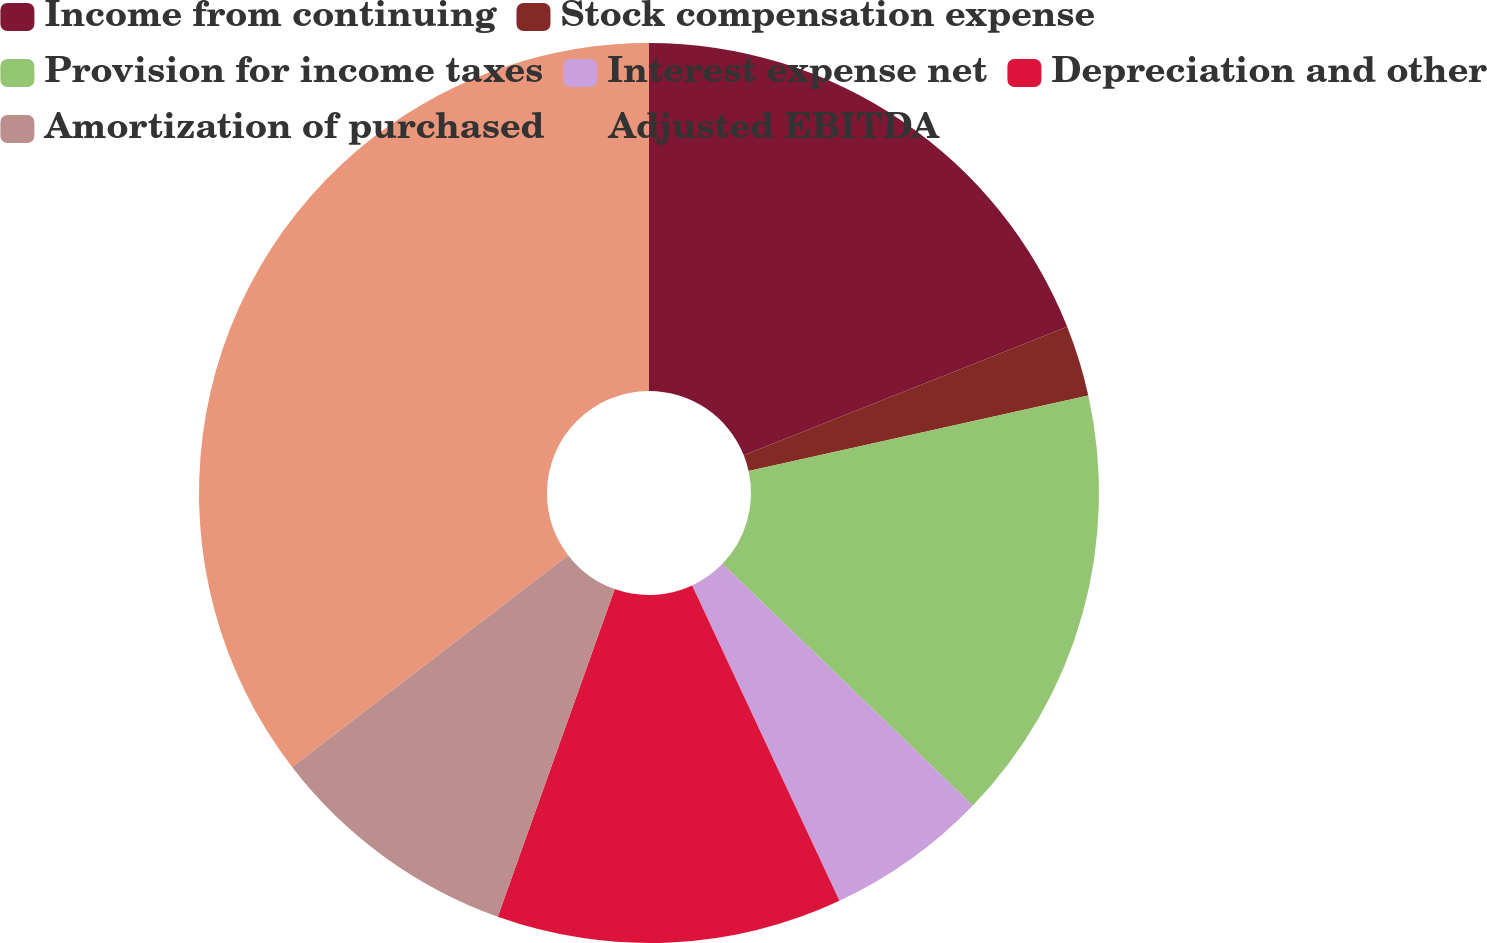<chart> <loc_0><loc_0><loc_500><loc_500><pie_chart><fcel>Income from continuing<fcel>Stock compensation expense<fcel>Provision for income taxes<fcel>Interest expense net<fcel>Depreciation and other<fcel>Amortization of purchased<fcel>Adjusted EBITDA<nl><fcel>18.98%<fcel>2.54%<fcel>15.69%<fcel>5.83%<fcel>12.41%<fcel>9.12%<fcel>35.42%<nl></chart> 